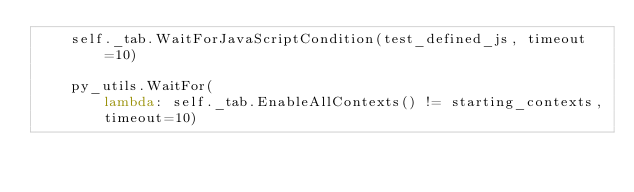<code> <loc_0><loc_0><loc_500><loc_500><_Python_>    self._tab.WaitForJavaScriptCondition(test_defined_js, timeout=10)

    py_utils.WaitFor(
        lambda: self._tab.EnableAllContexts() != starting_contexts,
        timeout=10)
</code> 